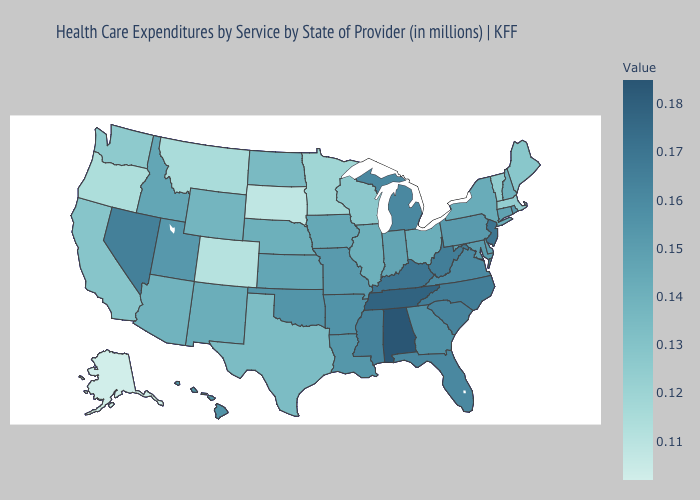Does Wyoming have the highest value in the West?
Give a very brief answer. No. Among the states that border Nevada , which have the lowest value?
Keep it brief. Oregon. Is the legend a continuous bar?
Be succinct. Yes. Which states hav the highest value in the West?
Keep it brief. Nevada. Among the states that border Illinois , does Wisconsin have the lowest value?
Write a very short answer. Yes. Does Nevada have the highest value in the West?
Short answer required. Yes. Does the map have missing data?
Quick response, please. No. Among the states that border New Mexico , which have the lowest value?
Short answer required. Colorado. 